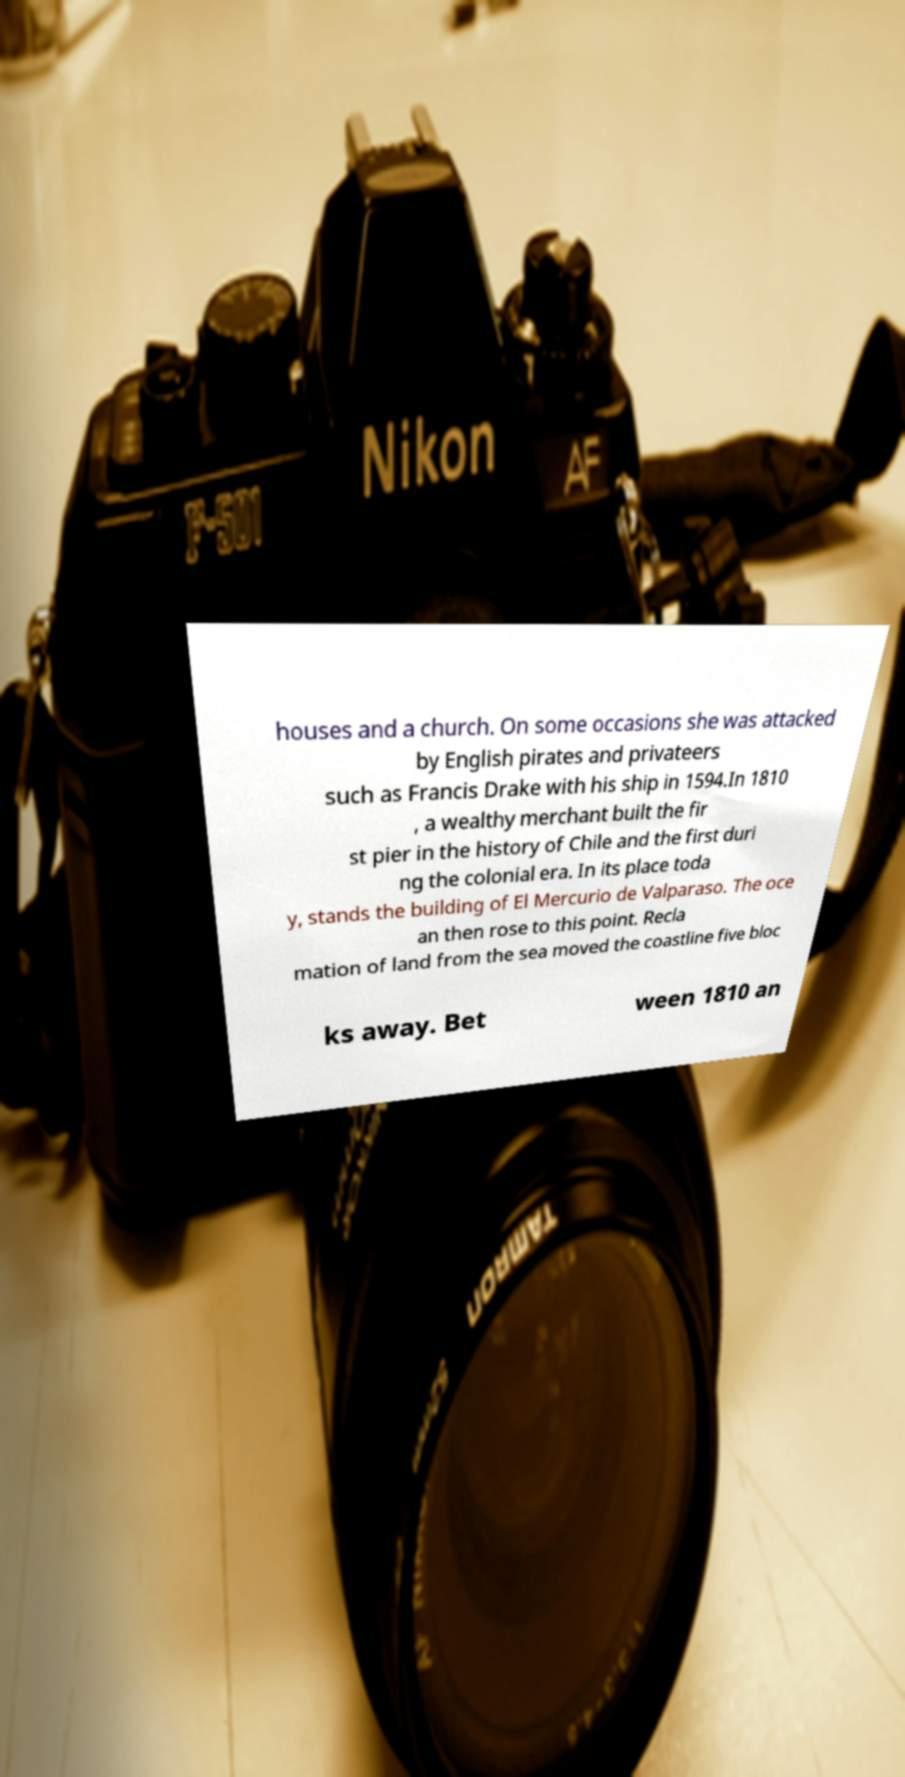What messages or text are displayed in this image? I need them in a readable, typed format. houses and a church. On some occasions she was attacked by English pirates and privateers such as Francis Drake with his ship in 1594.In 1810 , a wealthy merchant built the fir st pier in the history of Chile and the first duri ng the colonial era. In its place toda y, stands the building of El Mercurio de Valparaso. The oce an then rose to this point. Recla mation of land from the sea moved the coastline five bloc ks away. Bet ween 1810 an 